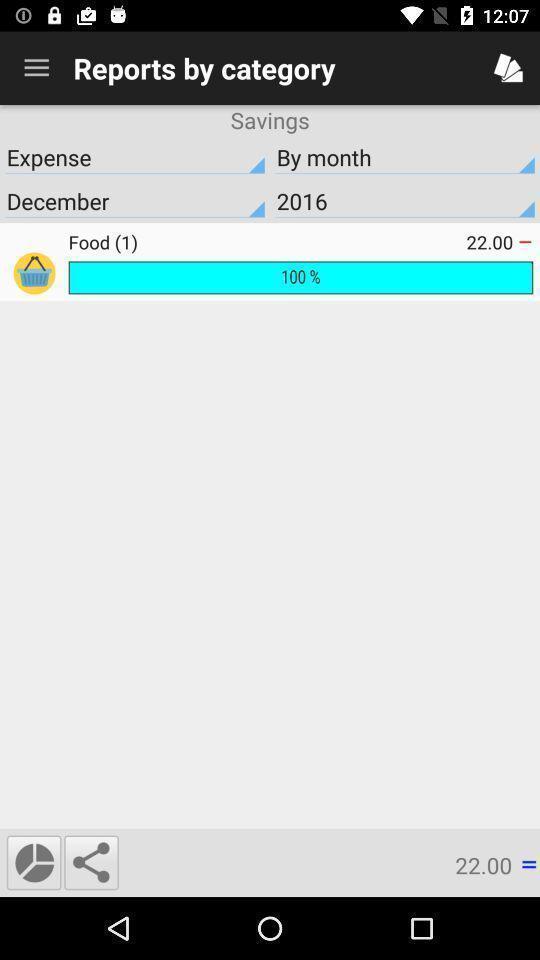Describe the content in this image. Reports for category of food expenses by month and year. 